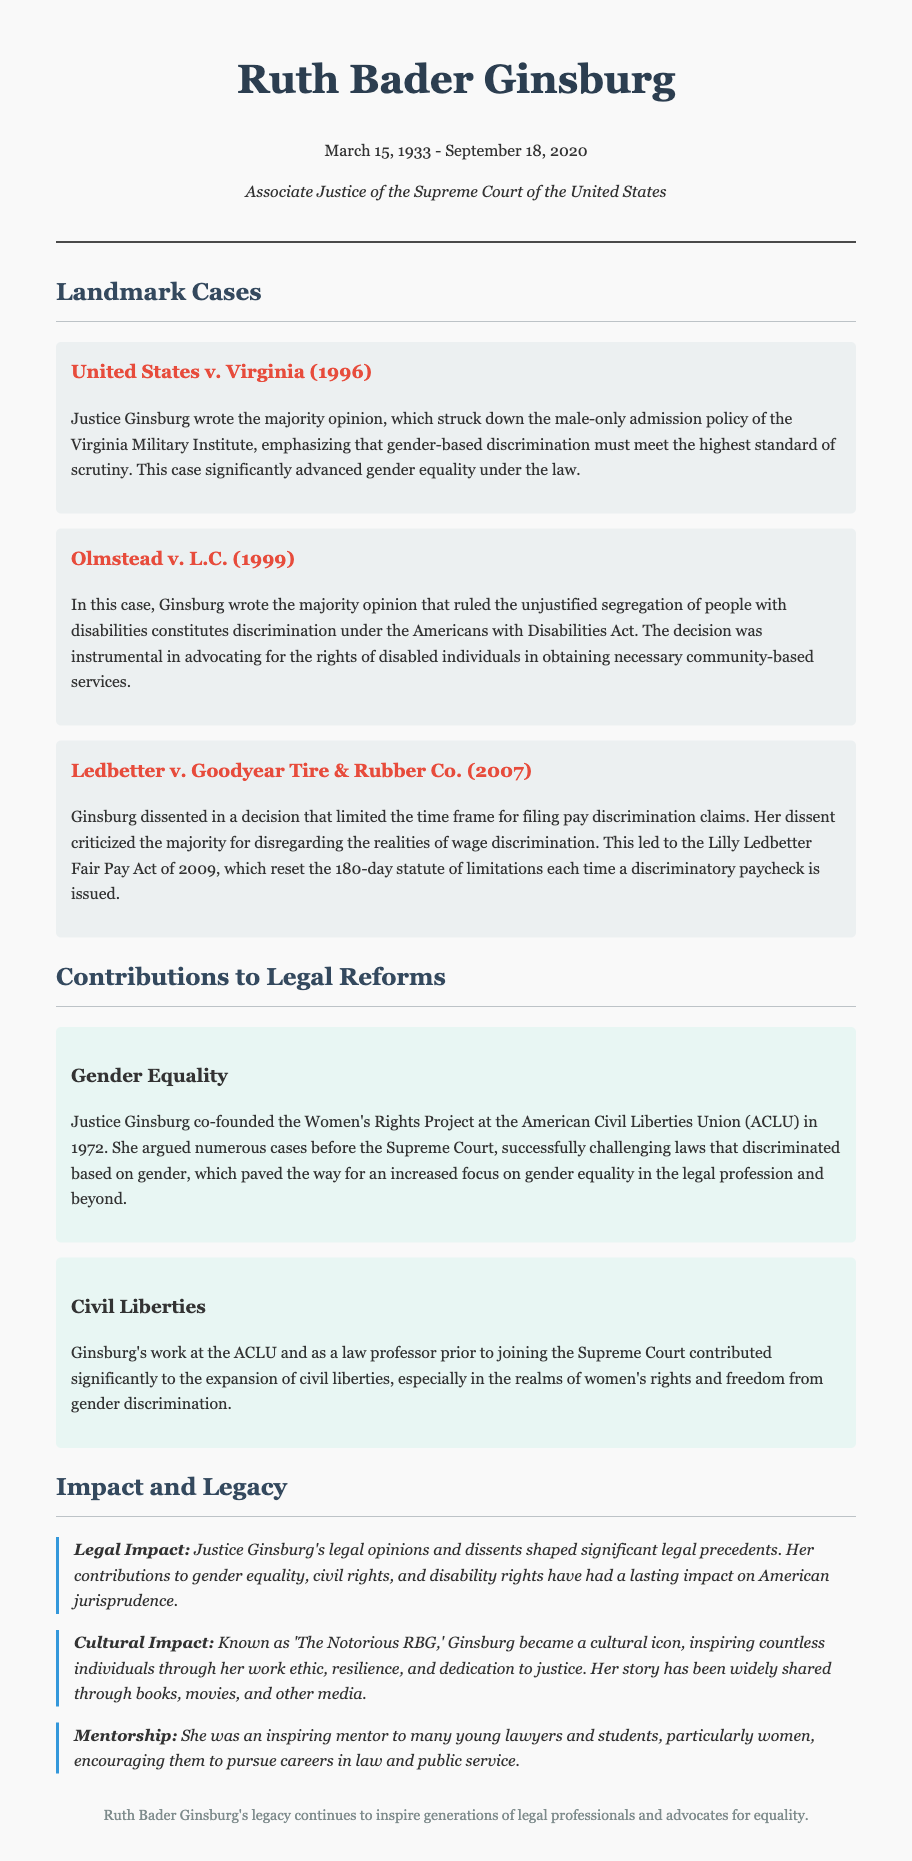what was the birth date of Ruth Bader Ginsburg? The document states the birth date of Ruth Bader Ginsburg as March 15, 1933.
Answer: March 15, 1933 what case did Ginsburg write the majority opinion for that involved the Virginia Military Institute? The document mentions United States v. Virginia as the case where she wrote the majority opinion regarding the Virginia Military Institute.
Answer: United States v. Virginia which act was a result of Ginsburg's dissent in Ledbetter v. Goodyear Tire & Rubber Co.? The document explains that Ginsburg's dissent led to the Lilly Ledbetter Fair Pay Act of 2009.
Answer: Lilly Ledbetter Fair Pay Act of 2009 in which year was the case Olmstead v. L.C. decided? The document indicates that the case Olmstead v. L.C. was decided in 1999.
Answer: 1999 what organization did Ginsburg co-found in 1972? According to the document, Ginsburg co-founded the Women's Rights Project at the American Civil Liberties Union (ACLU) in 1972.
Answer: Women's Rights Project at the ACLU how did Ginsburg's work contribute to civil liberties? The document states that her contributions at the ACLU and as a law professor significantly expanded civil liberties, especially regarding women's rights and freedom from gender discrimination.
Answer: Expanded civil liberties what is the cultural nickname associated with Ginsburg? The document refers to Ginsburg as 'The Notorious RBG.'
Answer: The Notorious RBG what key concept does Ginsburg's majority opinion in United States v. Virginia emphasize? The document highlights that her opinion emphasized that gender-based discrimination must meet the highest standard of scrutiny.
Answer: Highest standard of scrutiny 